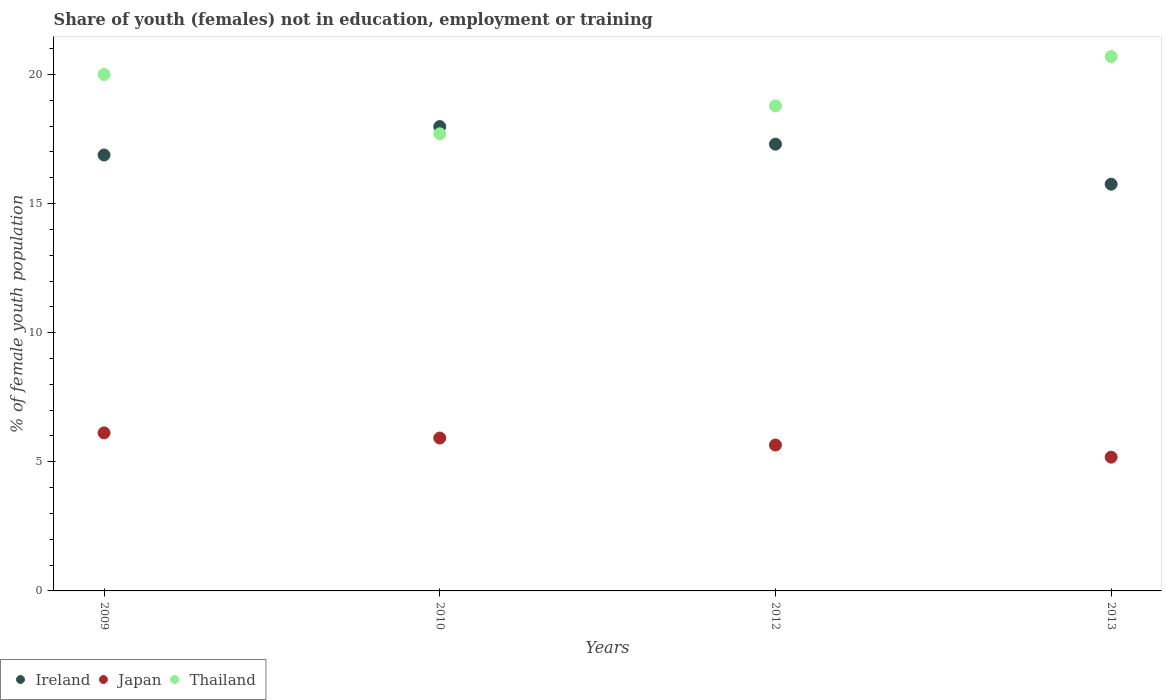Is the number of dotlines equal to the number of legend labels?
Ensure brevity in your answer.  Yes. What is the percentage of unemployed female population in in Ireland in 2009?
Ensure brevity in your answer.  16.88. Across all years, what is the maximum percentage of unemployed female population in in Ireland?
Your response must be concise. 17.98. Across all years, what is the minimum percentage of unemployed female population in in Thailand?
Ensure brevity in your answer.  17.7. What is the total percentage of unemployed female population in in Ireland in the graph?
Keep it short and to the point. 67.91. What is the difference between the percentage of unemployed female population in in Thailand in 2009 and that in 2010?
Keep it short and to the point. 2.3. What is the difference between the percentage of unemployed female population in in Japan in 2013 and the percentage of unemployed female population in in Ireland in 2010?
Your response must be concise. -12.8. What is the average percentage of unemployed female population in in Japan per year?
Keep it short and to the point. 5.72. In the year 2009, what is the difference between the percentage of unemployed female population in in Thailand and percentage of unemployed female population in in Ireland?
Offer a very short reply. 3.12. What is the ratio of the percentage of unemployed female population in in Japan in 2009 to that in 2013?
Give a very brief answer. 1.18. What is the difference between the highest and the second highest percentage of unemployed female population in in Ireland?
Provide a succinct answer. 0.68. What is the difference between the highest and the lowest percentage of unemployed female population in in Japan?
Offer a terse response. 0.94. Is the sum of the percentage of unemployed female population in in Ireland in 2009 and 2013 greater than the maximum percentage of unemployed female population in in Japan across all years?
Your answer should be very brief. Yes. Is it the case that in every year, the sum of the percentage of unemployed female population in in Japan and percentage of unemployed female population in in Ireland  is greater than the percentage of unemployed female population in in Thailand?
Give a very brief answer. Yes. Does the percentage of unemployed female population in in Thailand monotonically increase over the years?
Give a very brief answer. No. How many dotlines are there?
Your answer should be compact. 3. How many years are there in the graph?
Ensure brevity in your answer.  4. What is the difference between two consecutive major ticks on the Y-axis?
Make the answer very short. 5. Are the values on the major ticks of Y-axis written in scientific E-notation?
Give a very brief answer. No. Does the graph contain any zero values?
Make the answer very short. No. Does the graph contain grids?
Your answer should be compact. No. What is the title of the graph?
Provide a succinct answer. Share of youth (females) not in education, employment or training. Does "Serbia" appear as one of the legend labels in the graph?
Your response must be concise. No. What is the label or title of the Y-axis?
Your answer should be compact. % of female youth population. What is the % of female youth population of Ireland in 2009?
Keep it short and to the point. 16.88. What is the % of female youth population of Japan in 2009?
Offer a very short reply. 6.12. What is the % of female youth population in Thailand in 2009?
Keep it short and to the point. 20. What is the % of female youth population of Ireland in 2010?
Keep it short and to the point. 17.98. What is the % of female youth population of Japan in 2010?
Give a very brief answer. 5.92. What is the % of female youth population of Thailand in 2010?
Your answer should be very brief. 17.7. What is the % of female youth population in Ireland in 2012?
Ensure brevity in your answer.  17.3. What is the % of female youth population of Japan in 2012?
Keep it short and to the point. 5.65. What is the % of female youth population of Thailand in 2012?
Your response must be concise. 18.78. What is the % of female youth population in Ireland in 2013?
Keep it short and to the point. 15.75. What is the % of female youth population of Japan in 2013?
Make the answer very short. 5.18. What is the % of female youth population of Thailand in 2013?
Your answer should be compact. 20.69. Across all years, what is the maximum % of female youth population of Ireland?
Ensure brevity in your answer.  17.98. Across all years, what is the maximum % of female youth population of Japan?
Your answer should be very brief. 6.12. Across all years, what is the maximum % of female youth population in Thailand?
Provide a succinct answer. 20.69. Across all years, what is the minimum % of female youth population in Ireland?
Your response must be concise. 15.75. Across all years, what is the minimum % of female youth population in Japan?
Your answer should be compact. 5.18. Across all years, what is the minimum % of female youth population in Thailand?
Provide a succinct answer. 17.7. What is the total % of female youth population of Ireland in the graph?
Your answer should be compact. 67.91. What is the total % of female youth population of Japan in the graph?
Your response must be concise. 22.87. What is the total % of female youth population of Thailand in the graph?
Provide a short and direct response. 77.17. What is the difference between the % of female youth population of Ireland in 2009 and that in 2010?
Provide a succinct answer. -1.1. What is the difference between the % of female youth population in Japan in 2009 and that in 2010?
Provide a short and direct response. 0.2. What is the difference between the % of female youth population in Thailand in 2009 and that in 2010?
Offer a terse response. 2.3. What is the difference between the % of female youth population in Ireland in 2009 and that in 2012?
Your answer should be very brief. -0.42. What is the difference between the % of female youth population in Japan in 2009 and that in 2012?
Your response must be concise. 0.47. What is the difference between the % of female youth population of Thailand in 2009 and that in 2012?
Make the answer very short. 1.22. What is the difference between the % of female youth population of Ireland in 2009 and that in 2013?
Offer a very short reply. 1.13. What is the difference between the % of female youth population in Thailand in 2009 and that in 2013?
Provide a short and direct response. -0.69. What is the difference between the % of female youth population in Ireland in 2010 and that in 2012?
Offer a terse response. 0.68. What is the difference between the % of female youth population of Japan in 2010 and that in 2012?
Ensure brevity in your answer.  0.27. What is the difference between the % of female youth population in Thailand in 2010 and that in 2012?
Offer a terse response. -1.08. What is the difference between the % of female youth population of Ireland in 2010 and that in 2013?
Provide a succinct answer. 2.23. What is the difference between the % of female youth population in Japan in 2010 and that in 2013?
Your answer should be very brief. 0.74. What is the difference between the % of female youth population in Thailand in 2010 and that in 2013?
Your answer should be very brief. -2.99. What is the difference between the % of female youth population of Ireland in 2012 and that in 2013?
Offer a terse response. 1.55. What is the difference between the % of female youth population in Japan in 2012 and that in 2013?
Provide a short and direct response. 0.47. What is the difference between the % of female youth population in Thailand in 2012 and that in 2013?
Provide a short and direct response. -1.91. What is the difference between the % of female youth population in Ireland in 2009 and the % of female youth population in Japan in 2010?
Provide a succinct answer. 10.96. What is the difference between the % of female youth population of Ireland in 2009 and the % of female youth population of Thailand in 2010?
Your answer should be very brief. -0.82. What is the difference between the % of female youth population of Japan in 2009 and the % of female youth population of Thailand in 2010?
Ensure brevity in your answer.  -11.58. What is the difference between the % of female youth population of Ireland in 2009 and the % of female youth population of Japan in 2012?
Your answer should be compact. 11.23. What is the difference between the % of female youth population in Ireland in 2009 and the % of female youth population in Thailand in 2012?
Your answer should be very brief. -1.9. What is the difference between the % of female youth population in Japan in 2009 and the % of female youth population in Thailand in 2012?
Keep it short and to the point. -12.66. What is the difference between the % of female youth population of Ireland in 2009 and the % of female youth population of Thailand in 2013?
Offer a very short reply. -3.81. What is the difference between the % of female youth population in Japan in 2009 and the % of female youth population in Thailand in 2013?
Provide a short and direct response. -14.57. What is the difference between the % of female youth population of Ireland in 2010 and the % of female youth population of Japan in 2012?
Your response must be concise. 12.33. What is the difference between the % of female youth population of Japan in 2010 and the % of female youth population of Thailand in 2012?
Give a very brief answer. -12.86. What is the difference between the % of female youth population of Ireland in 2010 and the % of female youth population of Japan in 2013?
Offer a terse response. 12.8. What is the difference between the % of female youth population of Ireland in 2010 and the % of female youth population of Thailand in 2013?
Ensure brevity in your answer.  -2.71. What is the difference between the % of female youth population of Japan in 2010 and the % of female youth population of Thailand in 2013?
Give a very brief answer. -14.77. What is the difference between the % of female youth population of Ireland in 2012 and the % of female youth population of Japan in 2013?
Give a very brief answer. 12.12. What is the difference between the % of female youth population in Ireland in 2012 and the % of female youth population in Thailand in 2013?
Keep it short and to the point. -3.39. What is the difference between the % of female youth population of Japan in 2012 and the % of female youth population of Thailand in 2013?
Give a very brief answer. -15.04. What is the average % of female youth population of Ireland per year?
Ensure brevity in your answer.  16.98. What is the average % of female youth population in Japan per year?
Offer a terse response. 5.72. What is the average % of female youth population of Thailand per year?
Provide a short and direct response. 19.29. In the year 2009, what is the difference between the % of female youth population in Ireland and % of female youth population in Japan?
Your answer should be very brief. 10.76. In the year 2009, what is the difference between the % of female youth population of Ireland and % of female youth population of Thailand?
Your answer should be very brief. -3.12. In the year 2009, what is the difference between the % of female youth population of Japan and % of female youth population of Thailand?
Give a very brief answer. -13.88. In the year 2010, what is the difference between the % of female youth population of Ireland and % of female youth population of Japan?
Provide a short and direct response. 12.06. In the year 2010, what is the difference between the % of female youth population of Ireland and % of female youth population of Thailand?
Your answer should be very brief. 0.28. In the year 2010, what is the difference between the % of female youth population in Japan and % of female youth population in Thailand?
Keep it short and to the point. -11.78. In the year 2012, what is the difference between the % of female youth population in Ireland and % of female youth population in Japan?
Your response must be concise. 11.65. In the year 2012, what is the difference between the % of female youth population of Ireland and % of female youth population of Thailand?
Make the answer very short. -1.48. In the year 2012, what is the difference between the % of female youth population of Japan and % of female youth population of Thailand?
Provide a succinct answer. -13.13. In the year 2013, what is the difference between the % of female youth population of Ireland and % of female youth population of Japan?
Keep it short and to the point. 10.57. In the year 2013, what is the difference between the % of female youth population in Ireland and % of female youth population in Thailand?
Your response must be concise. -4.94. In the year 2013, what is the difference between the % of female youth population of Japan and % of female youth population of Thailand?
Keep it short and to the point. -15.51. What is the ratio of the % of female youth population in Ireland in 2009 to that in 2010?
Make the answer very short. 0.94. What is the ratio of the % of female youth population of Japan in 2009 to that in 2010?
Ensure brevity in your answer.  1.03. What is the ratio of the % of female youth population of Thailand in 2009 to that in 2010?
Make the answer very short. 1.13. What is the ratio of the % of female youth population in Ireland in 2009 to that in 2012?
Offer a very short reply. 0.98. What is the ratio of the % of female youth population of Japan in 2009 to that in 2012?
Make the answer very short. 1.08. What is the ratio of the % of female youth population of Thailand in 2009 to that in 2012?
Provide a succinct answer. 1.06. What is the ratio of the % of female youth population of Ireland in 2009 to that in 2013?
Keep it short and to the point. 1.07. What is the ratio of the % of female youth population of Japan in 2009 to that in 2013?
Offer a terse response. 1.18. What is the ratio of the % of female youth population in Thailand in 2009 to that in 2013?
Offer a terse response. 0.97. What is the ratio of the % of female youth population in Ireland in 2010 to that in 2012?
Offer a terse response. 1.04. What is the ratio of the % of female youth population in Japan in 2010 to that in 2012?
Give a very brief answer. 1.05. What is the ratio of the % of female youth population in Thailand in 2010 to that in 2012?
Your answer should be compact. 0.94. What is the ratio of the % of female youth population of Ireland in 2010 to that in 2013?
Make the answer very short. 1.14. What is the ratio of the % of female youth population in Thailand in 2010 to that in 2013?
Offer a very short reply. 0.86. What is the ratio of the % of female youth population in Ireland in 2012 to that in 2013?
Offer a very short reply. 1.1. What is the ratio of the % of female youth population in Japan in 2012 to that in 2013?
Provide a short and direct response. 1.09. What is the ratio of the % of female youth population of Thailand in 2012 to that in 2013?
Provide a succinct answer. 0.91. What is the difference between the highest and the second highest % of female youth population in Ireland?
Your answer should be compact. 0.68. What is the difference between the highest and the second highest % of female youth population of Japan?
Your answer should be very brief. 0.2. What is the difference between the highest and the second highest % of female youth population of Thailand?
Offer a very short reply. 0.69. What is the difference between the highest and the lowest % of female youth population of Ireland?
Give a very brief answer. 2.23. What is the difference between the highest and the lowest % of female youth population in Thailand?
Your answer should be very brief. 2.99. 